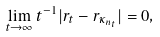Convert formula to latex. <formula><loc_0><loc_0><loc_500><loc_500>\lim _ { t \to \infty } t ^ { - 1 } | r _ { t } - r _ { \kappa _ { n _ { t } } } | = 0 ,</formula> 